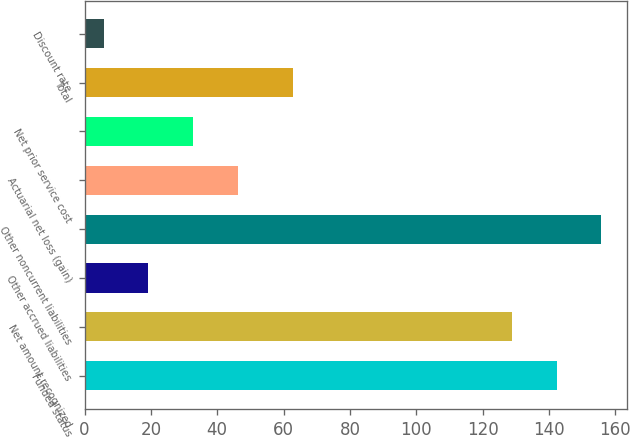Convert chart to OTSL. <chart><loc_0><loc_0><loc_500><loc_500><bar_chart><fcel>Funded status<fcel>Net amount recognized<fcel>Other accrued liabilities<fcel>Other noncurrent liabilities<fcel>Actuarial net loss (gain)<fcel>Net prior service cost<fcel>Total<fcel>Discount rate<nl><fcel>142.36<fcel>128.9<fcel>19.21<fcel>155.82<fcel>46.12<fcel>32.67<fcel>62.7<fcel>5.75<nl></chart> 